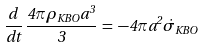<formula> <loc_0><loc_0><loc_500><loc_500>\frac { d } { d t } \, \frac { 4 { \pi } { \rho } _ { K B O } a ^ { 3 } } { 3 } \, = \, - 4 { \pi } a ^ { 2 } { \dot { \sigma } _ { K B O } }</formula> 